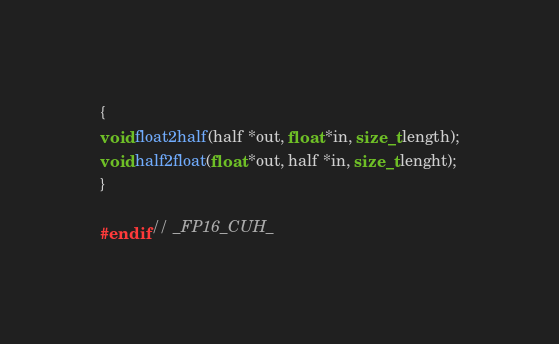Convert code to text. <code><loc_0><loc_0><loc_500><loc_500><_Cuda_>{
void float2half(half *out, float *in, size_t length);
void half2float(float *out, half *in, size_t lenght);
}

#endif // _FP16_CUH_</code> 